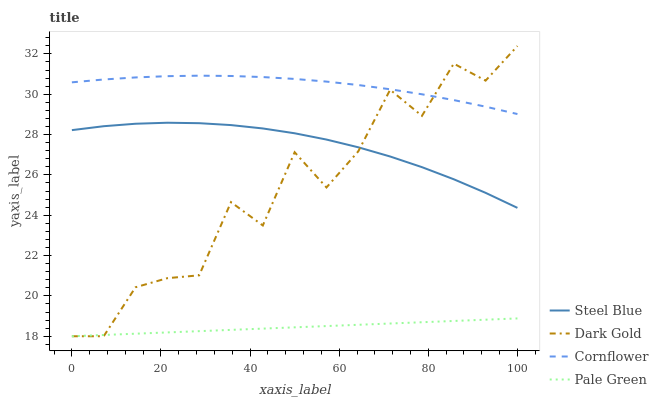Does Pale Green have the minimum area under the curve?
Answer yes or no. Yes. Does Cornflower have the maximum area under the curve?
Answer yes or no. Yes. Does Steel Blue have the minimum area under the curve?
Answer yes or no. No. Does Steel Blue have the maximum area under the curve?
Answer yes or no. No. Is Pale Green the smoothest?
Answer yes or no. Yes. Is Dark Gold the roughest?
Answer yes or no. Yes. Is Steel Blue the smoothest?
Answer yes or no. No. Is Steel Blue the roughest?
Answer yes or no. No. Does Steel Blue have the lowest value?
Answer yes or no. No. Does Steel Blue have the highest value?
Answer yes or no. No. Is Pale Green less than Cornflower?
Answer yes or no. Yes. Is Cornflower greater than Pale Green?
Answer yes or no. Yes. Does Pale Green intersect Cornflower?
Answer yes or no. No. 